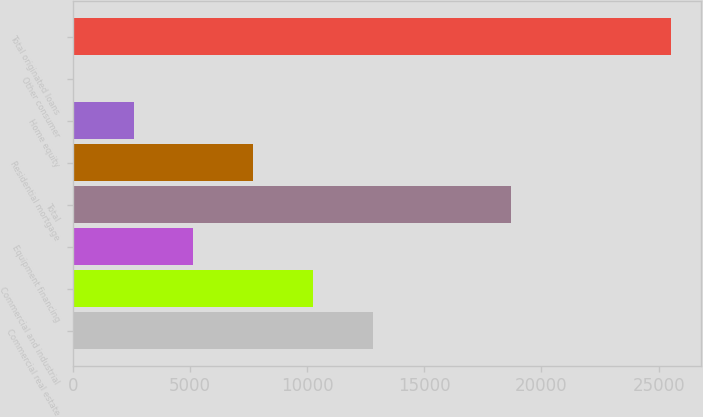Convert chart to OTSL. <chart><loc_0><loc_0><loc_500><loc_500><bar_chart><fcel>Commercial real estate<fcel>Commercial and industrial<fcel>Equipment financing<fcel>Total<fcel>Residential mortgage<fcel>Home equity<fcel>Other consumer<fcel>Total originated loans<nl><fcel>12798.7<fcel>10250.2<fcel>5153.26<fcel>18690.4<fcel>7701.74<fcel>2604.78<fcel>56.3<fcel>25541.1<nl></chart> 